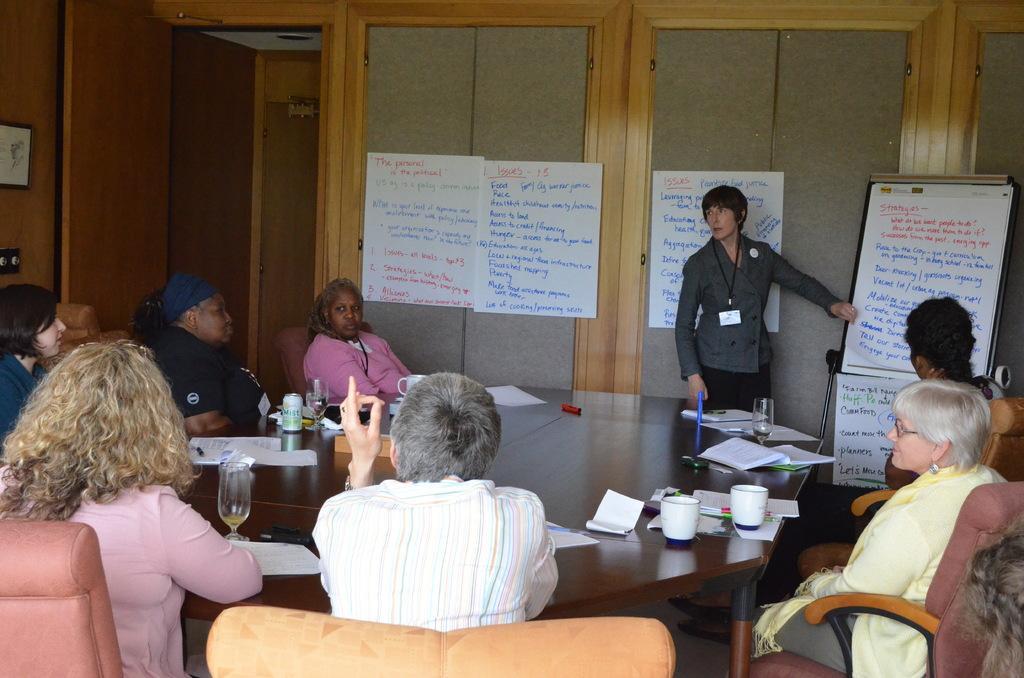How would you summarize this image in a sentence or two? In this picture there are group of people, they are sitting around the table and there is a board at the right side of the image and the lady who is standing at the right side of the image she is explaining from the board and there is a door at the left side of the image. 